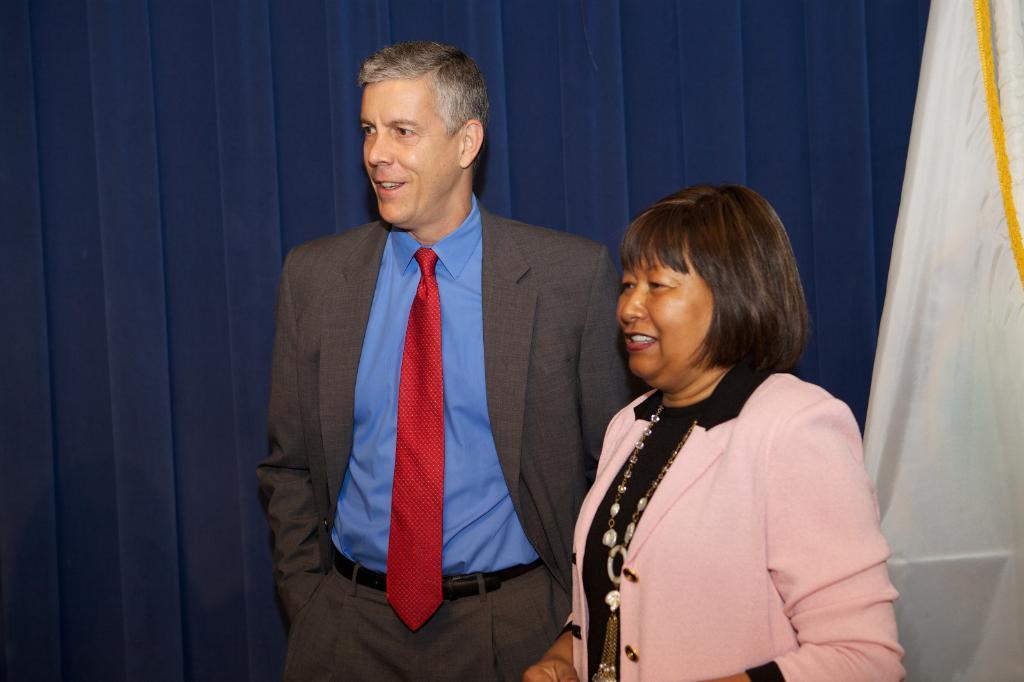How many people are in the image? There are two people in the image. What are the people doing in the image? The people are standing and smiling. What can be seen in the background of the image? There is a curtain and a flag in the background of the image. What type of berry is being used as a prop in the image? There is no berry present in the image. What did the people have for breakfast before posing for the image? The provided facts do not mention anything about breakfast, so it cannot be determined from the image. 